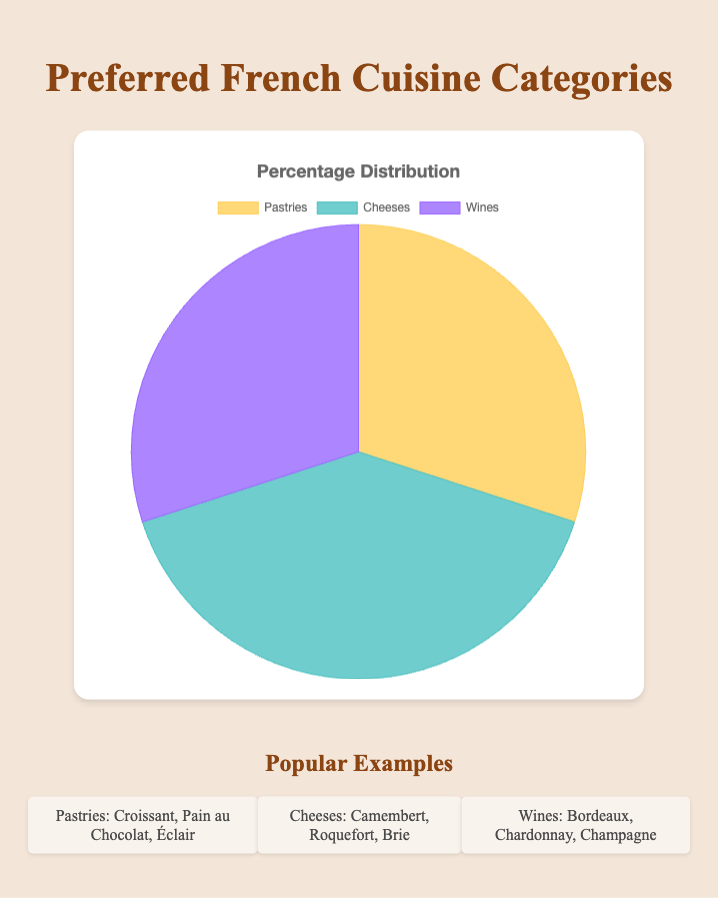What percentage of the pie chart is dedicated to Pastries and Wines combined? Add the percentages of Pastries (30%) and Wines (30%). Thus, the combined percentage is 30% + 30% = 60%.
Answer: 60% Which category occupies the largest portion of the pie chart? Compare the percentages of Pastries (30%), Cheeses (40%), and Wines (30%). The largest percentage is 40%, which corresponds to Cheeses.
Answer: Cheeses How do the percentages of Pastries and Wines compare to the percentage of Cheeses? Add the percentages of Pastries (30%) and Wines (30%) to get 60%, and compare it to the percentage of Cheeses (40%). Pastries and Wines combined (60%) are greater than Cheeses (40%).
Answer: Pastries and Wines combined are greater If the pie chart were divided into 10 equal parts, how many parts would represent Cheeses? The percentage for Cheeses is 40%. Since the pie chart is 100%, each equal part would be 10%. Thus, 40% translates into 4 parts out of 10.
Answer: 4 parts What color represents the Wines category in the pie chart? Identify the color corresponding to the Wines section in the pie chart, which is purple.
Answer: purple Which two categories together make up 60% of the pie chart? Combine the percentages of Pastries (30%) and Wines (30%) to see they sum to 60%.
Answer: Pastries and Wines What is the difference in percentage between Cheeses and each of the other two categories? The difference between Cheeses and Pastries is 40% - 30% = 10%, and the difference between Cheeses and Wines is 40% - 30% = 10%.
Answer: 10% How many total categories make up the pie chart? The pie chart has three distinct categories: Pastries, Cheeses, and Wines.
Answer: 3 Which categories have equal percentages in the pie chart? Both Pastries and Wines have the same percentage of 30%.
Answer: Pastries and Wines 